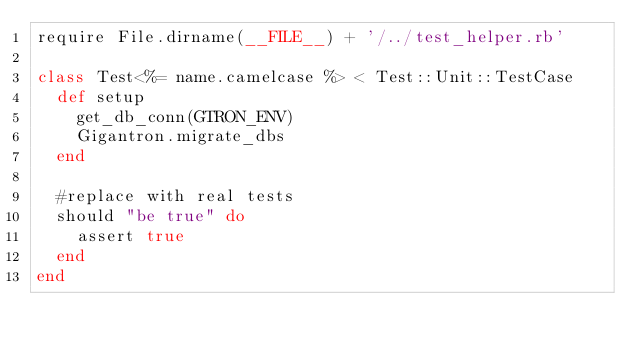Convert code to text. <code><loc_0><loc_0><loc_500><loc_500><_Ruby_>require File.dirname(__FILE__) + '/../test_helper.rb'

class Test<%= name.camelcase %> < Test::Unit::TestCase
  def setup
    get_db_conn(GTRON_ENV)
    Gigantron.migrate_dbs
  end

  #replace with real tests
  should "be true" do
    assert true
  end
end
</code> 